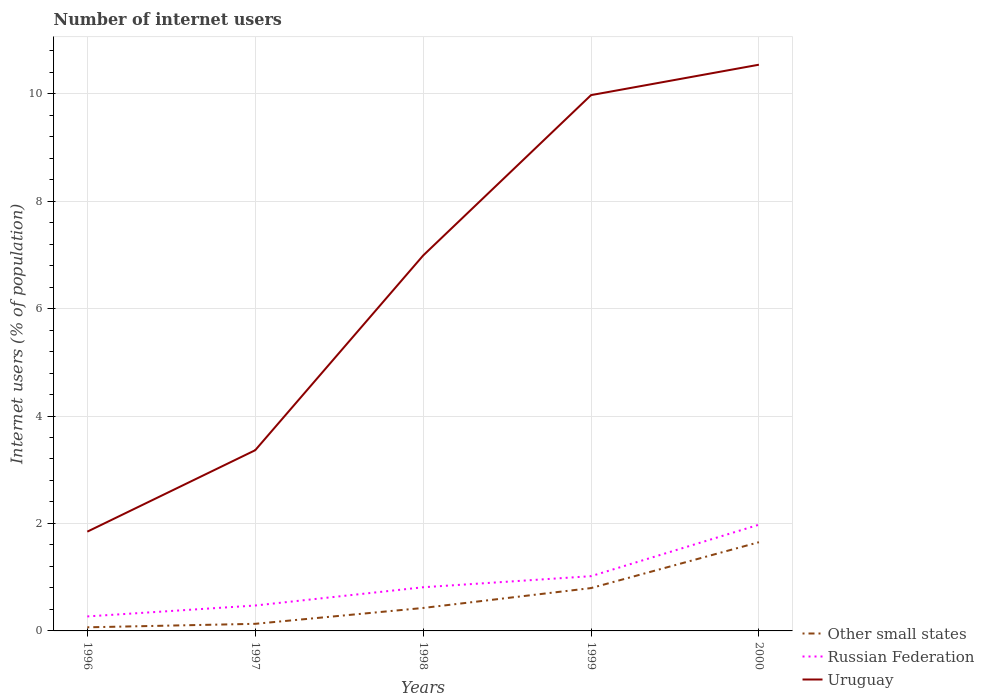How many different coloured lines are there?
Offer a terse response. 3. Does the line corresponding to Russian Federation intersect with the line corresponding to Other small states?
Your response must be concise. No. Is the number of lines equal to the number of legend labels?
Ensure brevity in your answer.  Yes. Across all years, what is the maximum number of internet users in Other small states?
Provide a short and direct response. 0.07. What is the total number of internet users in Uruguay in the graph?
Offer a terse response. -5.14. What is the difference between the highest and the second highest number of internet users in Uruguay?
Give a very brief answer. 8.69. Is the number of internet users in Other small states strictly greater than the number of internet users in Uruguay over the years?
Provide a short and direct response. Yes. How many lines are there?
Make the answer very short. 3. Are the values on the major ticks of Y-axis written in scientific E-notation?
Offer a very short reply. No. Does the graph contain any zero values?
Your answer should be very brief. No. Does the graph contain grids?
Your answer should be compact. Yes. Where does the legend appear in the graph?
Give a very brief answer. Bottom right. What is the title of the graph?
Ensure brevity in your answer.  Number of internet users. What is the label or title of the X-axis?
Offer a terse response. Years. What is the label or title of the Y-axis?
Your answer should be compact. Internet users (% of population). What is the Internet users (% of population) of Other small states in 1996?
Make the answer very short. 0.07. What is the Internet users (% of population) of Russian Federation in 1996?
Offer a very short reply. 0.27. What is the Internet users (% of population) in Uruguay in 1996?
Your answer should be very brief. 1.85. What is the Internet users (% of population) in Other small states in 1997?
Give a very brief answer. 0.13. What is the Internet users (% of population) of Russian Federation in 1997?
Make the answer very short. 0.47. What is the Internet users (% of population) in Uruguay in 1997?
Provide a short and direct response. 3.36. What is the Internet users (% of population) in Other small states in 1998?
Provide a short and direct response. 0.43. What is the Internet users (% of population) in Russian Federation in 1998?
Give a very brief answer. 0.81. What is the Internet users (% of population) of Uruguay in 1998?
Ensure brevity in your answer.  6.99. What is the Internet users (% of population) of Other small states in 1999?
Offer a terse response. 0.8. What is the Internet users (% of population) in Russian Federation in 1999?
Your response must be concise. 1.02. What is the Internet users (% of population) of Uruguay in 1999?
Make the answer very short. 9.97. What is the Internet users (% of population) of Other small states in 2000?
Your answer should be compact. 1.65. What is the Internet users (% of population) of Russian Federation in 2000?
Provide a short and direct response. 1.98. What is the Internet users (% of population) in Uruguay in 2000?
Make the answer very short. 10.54. Across all years, what is the maximum Internet users (% of population) in Other small states?
Provide a succinct answer. 1.65. Across all years, what is the maximum Internet users (% of population) in Russian Federation?
Give a very brief answer. 1.98. Across all years, what is the maximum Internet users (% of population) of Uruguay?
Your response must be concise. 10.54. Across all years, what is the minimum Internet users (% of population) of Other small states?
Offer a terse response. 0.07. Across all years, what is the minimum Internet users (% of population) in Russian Federation?
Provide a succinct answer. 0.27. Across all years, what is the minimum Internet users (% of population) of Uruguay?
Give a very brief answer. 1.85. What is the total Internet users (% of population) in Other small states in the graph?
Your response must be concise. 3.08. What is the total Internet users (% of population) in Russian Federation in the graph?
Keep it short and to the point. 4.55. What is the total Internet users (% of population) in Uruguay in the graph?
Make the answer very short. 32.71. What is the difference between the Internet users (% of population) of Other small states in 1996 and that in 1997?
Your answer should be very brief. -0.06. What is the difference between the Internet users (% of population) in Russian Federation in 1996 and that in 1997?
Provide a short and direct response. -0.2. What is the difference between the Internet users (% of population) of Uruguay in 1996 and that in 1997?
Keep it short and to the point. -1.52. What is the difference between the Internet users (% of population) of Other small states in 1996 and that in 1998?
Ensure brevity in your answer.  -0.36. What is the difference between the Internet users (% of population) of Russian Federation in 1996 and that in 1998?
Offer a terse response. -0.54. What is the difference between the Internet users (% of population) in Uruguay in 1996 and that in 1998?
Provide a short and direct response. -5.14. What is the difference between the Internet users (% of population) in Other small states in 1996 and that in 1999?
Offer a very short reply. -0.73. What is the difference between the Internet users (% of population) of Russian Federation in 1996 and that in 1999?
Your answer should be compact. -0.75. What is the difference between the Internet users (% of population) in Uruguay in 1996 and that in 1999?
Your answer should be very brief. -8.13. What is the difference between the Internet users (% of population) of Other small states in 1996 and that in 2000?
Provide a short and direct response. -1.58. What is the difference between the Internet users (% of population) of Russian Federation in 1996 and that in 2000?
Provide a succinct answer. -1.71. What is the difference between the Internet users (% of population) of Uruguay in 1996 and that in 2000?
Keep it short and to the point. -8.69. What is the difference between the Internet users (% of population) in Other small states in 1997 and that in 1998?
Offer a terse response. -0.3. What is the difference between the Internet users (% of population) of Russian Federation in 1997 and that in 1998?
Provide a succinct answer. -0.34. What is the difference between the Internet users (% of population) in Uruguay in 1997 and that in 1998?
Your response must be concise. -3.62. What is the difference between the Internet users (% of population) of Other small states in 1997 and that in 1999?
Give a very brief answer. -0.67. What is the difference between the Internet users (% of population) of Russian Federation in 1997 and that in 1999?
Offer a very short reply. -0.55. What is the difference between the Internet users (% of population) in Uruguay in 1997 and that in 1999?
Make the answer very short. -6.61. What is the difference between the Internet users (% of population) of Other small states in 1997 and that in 2000?
Give a very brief answer. -1.52. What is the difference between the Internet users (% of population) in Russian Federation in 1997 and that in 2000?
Offer a very short reply. -1.5. What is the difference between the Internet users (% of population) in Uruguay in 1997 and that in 2000?
Ensure brevity in your answer.  -7.18. What is the difference between the Internet users (% of population) in Other small states in 1998 and that in 1999?
Make the answer very short. -0.37. What is the difference between the Internet users (% of population) of Russian Federation in 1998 and that in 1999?
Make the answer very short. -0.21. What is the difference between the Internet users (% of population) of Uruguay in 1998 and that in 1999?
Keep it short and to the point. -2.99. What is the difference between the Internet users (% of population) of Other small states in 1998 and that in 2000?
Ensure brevity in your answer.  -1.22. What is the difference between the Internet users (% of population) of Russian Federation in 1998 and that in 2000?
Ensure brevity in your answer.  -1.16. What is the difference between the Internet users (% of population) in Uruguay in 1998 and that in 2000?
Provide a succinct answer. -3.55. What is the difference between the Internet users (% of population) in Other small states in 1999 and that in 2000?
Your response must be concise. -0.85. What is the difference between the Internet users (% of population) in Russian Federation in 1999 and that in 2000?
Offer a very short reply. -0.96. What is the difference between the Internet users (% of population) in Uruguay in 1999 and that in 2000?
Provide a succinct answer. -0.57. What is the difference between the Internet users (% of population) of Other small states in 1996 and the Internet users (% of population) of Russian Federation in 1997?
Your response must be concise. -0.41. What is the difference between the Internet users (% of population) of Other small states in 1996 and the Internet users (% of population) of Uruguay in 1997?
Offer a terse response. -3.3. What is the difference between the Internet users (% of population) of Russian Federation in 1996 and the Internet users (% of population) of Uruguay in 1997?
Your response must be concise. -3.09. What is the difference between the Internet users (% of population) of Other small states in 1996 and the Internet users (% of population) of Russian Federation in 1998?
Your answer should be very brief. -0.75. What is the difference between the Internet users (% of population) in Other small states in 1996 and the Internet users (% of population) in Uruguay in 1998?
Provide a short and direct response. -6.92. What is the difference between the Internet users (% of population) in Russian Federation in 1996 and the Internet users (% of population) in Uruguay in 1998?
Give a very brief answer. -6.72. What is the difference between the Internet users (% of population) of Other small states in 1996 and the Internet users (% of population) of Russian Federation in 1999?
Provide a short and direct response. -0.95. What is the difference between the Internet users (% of population) of Other small states in 1996 and the Internet users (% of population) of Uruguay in 1999?
Give a very brief answer. -9.91. What is the difference between the Internet users (% of population) of Russian Federation in 1996 and the Internet users (% of population) of Uruguay in 1999?
Provide a succinct answer. -9.7. What is the difference between the Internet users (% of population) in Other small states in 1996 and the Internet users (% of population) in Russian Federation in 2000?
Offer a terse response. -1.91. What is the difference between the Internet users (% of population) of Other small states in 1996 and the Internet users (% of population) of Uruguay in 2000?
Offer a terse response. -10.47. What is the difference between the Internet users (% of population) in Russian Federation in 1996 and the Internet users (% of population) in Uruguay in 2000?
Your answer should be very brief. -10.27. What is the difference between the Internet users (% of population) of Other small states in 1997 and the Internet users (% of population) of Russian Federation in 1998?
Your answer should be compact. -0.68. What is the difference between the Internet users (% of population) of Other small states in 1997 and the Internet users (% of population) of Uruguay in 1998?
Offer a terse response. -6.85. What is the difference between the Internet users (% of population) in Russian Federation in 1997 and the Internet users (% of population) in Uruguay in 1998?
Ensure brevity in your answer.  -6.51. What is the difference between the Internet users (% of population) of Other small states in 1997 and the Internet users (% of population) of Russian Federation in 1999?
Give a very brief answer. -0.89. What is the difference between the Internet users (% of population) of Other small states in 1997 and the Internet users (% of population) of Uruguay in 1999?
Ensure brevity in your answer.  -9.84. What is the difference between the Internet users (% of population) in Russian Federation in 1997 and the Internet users (% of population) in Uruguay in 1999?
Offer a very short reply. -9.5. What is the difference between the Internet users (% of population) in Other small states in 1997 and the Internet users (% of population) in Russian Federation in 2000?
Offer a very short reply. -1.85. What is the difference between the Internet users (% of population) of Other small states in 1997 and the Internet users (% of population) of Uruguay in 2000?
Offer a terse response. -10.41. What is the difference between the Internet users (% of population) in Russian Federation in 1997 and the Internet users (% of population) in Uruguay in 2000?
Give a very brief answer. -10.07. What is the difference between the Internet users (% of population) of Other small states in 1998 and the Internet users (% of population) of Russian Federation in 1999?
Ensure brevity in your answer.  -0.59. What is the difference between the Internet users (% of population) in Other small states in 1998 and the Internet users (% of population) in Uruguay in 1999?
Your answer should be compact. -9.55. What is the difference between the Internet users (% of population) of Russian Federation in 1998 and the Internet users (% of population) of Uruguay in 1999?
Give a very brief answer. -9.16. What is the difference between the Internet users (% of population) of Other small states in 1998 and the Internet users (% of population) of Russian Federation in 2000?
Make the answer very short. -1.55. What is the difference between the Internet users (% of population) in Other small states in 1998 and the Internet users (% of population) in Uruguay in 2000?
Your response must be concise. -10.11. What is the difference between the Internet users (% of population) in Russian Federation in 1998 and the Internet users (% of population) in Uruguay in 2000?
Your response must be concise. -9.73. What is the difference between the Internet users (% of population) in Other small states in 1999 and the Internet users (% of population) in Russian Federation in 2000?
Make the answer very short. -1.18. What is the difference between the Internet users (% of population) in Other small states in 1999 and the Internet users (% of population) in Uruguay in 2000?
Your answer should be compact. -9.74. What is the difference between the Internet users (% of population) in Russian Federation in 1999 and the Internet users (% of population) in Uruguay in 2000?
Ensure brevity in your answer.  -9.52. What is the average Internet users (% of population) of Other small states per year?
Your response must be concise. 0.62. What is the average Internet users (% of population) of Russian Federation per year?
Make the answer very short. 0.91. What is the average Internet users (% of population) in Uruguay per year?
Keep it short and to the point. 6.54. In the year 1996, what is the difference between the Internet users (% of population) of Other small states and Internet users (% of population) of Russian Federation?
Provide a short and direct response. -0.2. In the year 1996, what is the difference between the Internet users (% of population) in Other small states and Internet users (% of population) in Uruguay?
Offer a very short reply. -1.78. In the year 1996, what is the difference between the Internet users (% of population) in Russian Federation and Internet users (% of population) in Uruguay?
Offer a very short reply. -1.58. In the year 1997, what is the difference between the Internet users (% of population) in Other small states and Internet users (% of population) in Russian Federation?
Offer a very short reply. -0.34. In the year 1997, what is the difference between the Internet users (% of population) of Other small states and Internet users (% of population) of Uruguay?
Offer a very short reply. -3.23. In the year 1997, what is the difference between the Internet users (% of population) in Russian Federation and Internet users (% of population) in Uruguay?
Ensure brevity in your answer.  -2.89. In the year 1998, what is the difference between the Internet users (% of population) of Other small states and Internet users (% of population) of Russian Federation?
Make the answer very short. -0.39. In the year 1998, what is the difference between the Internet users (% of population) in Other small states and Internet users (% of population) in Uruguay?
Keep it short and to the point. -6.56. In the year 1998, what is the difference between the Internet users (% of population) of Russian Federation and Internet users (% of population) of Uruguay?
Provide a short and direct response. -6.17. In the year 1999, what is the difference between the Internet users (% of population) of Other small states and Internet users (% of population) of Russian Federation?
Your response must be concise. -0.22. In the year 1999, what is the difference between the Internet users (% of population) in Other small states and Internet users (% of population) in Uruguay?
Make the answer very short. -9.18. In the year 1999, what is the difference between the Internet users (% of population) of Russian Federation and Internet users (% of population) of Uruguay?
Your answer should be compact. -8.95. In the year 2000, what is the difference between the Internet users (% of population) of Other small states and Internet users (% of population) of Russian Federation?
Offer a terse response. -0.33. In the year 2000, what is the difference between the Internet users (% of population) of Other small states and Internet users (% of population) of Uruguay?
Ensure brevity in your answer.  -8.89. In the year 2000, what is the difference between the Internet users (% of population) of Russian Federation and Internet users (% of population) of Uruguay?
Offer a terse response. -8.56. What is the ratio of the Internet users (% of population) in Other small states in 1996 to that in 1997?
Offer a very short reply. 0.51. What is the ratio of the Internet users (% of population) in Russian Federation in 1996 to that in 1997?
Keep it short and to the point. 0.57. What is the ratio of the Internet users (% of population) in Uruguay in 1996 to that in 1997?
Offer a very short reply. 0.55. What is the ratio of the Internet users (% of population) in Other small states in 1996 to that in 1998?
Give a very brief answer. 0.16. What is the ratio of the Internet users (% of population) of Russian Federation in 1996 to that in 1998?
Offer a very short reply. 0.33. What is the ratio of the Internet users (% of population) in Uruguay in 1996 to that in 1998?
Keep it short and to the point. 0.26. What is the ratio of the Internet users (% of population) of Other small states in 1996 to that in 1999?
Give a very brief answer. 0.08. What is the ratio of the Internet users (% of population) in Russian Federation in 1996 to that in 1999?
Provide a short and direct response. 0.26. What is the ratio of the Internet users (% of population) of Uruguay in 1996 to that in 1999?
Provide a short and direct response. 0.19. What is the ratio of the Internet users (% of population) of Other small states in 1996 to that in 2000?
Your answer should be compact. 0.04. What is the ratio of the Internet users (% of population) of Russian Federation in 1996 to that in 2000?
Make the answer very short. 0.14. What is the ratio of the Internet users (% of population) in Uruguay in 1996 to that in 2000?
Keep it short and to the point. 0.18. What is the ratio of the Internet users (% of population) in Other small states in 1997 to that in 1998?
Your answer should be very brief. 0.31. What is the ratio of the Internet users (% of population) of Russian Federation in 1997 to that in 1998?
Give a very brief answer. 0.58. What is the ratio of the Internet users (% of population) in Uruguay in 1997 to that in 1998?
Provide a short and direct response. 0.48. What is the ratio of the Internet users (% of population) of Other small states in 1997 to that in 1999?
Offer a terse response. 0.17. What is the ratio of the Internet users (% of population) of Russian Federation in 1997 to that in 1999?
Ensure brevity in your answer.  0.46. What is the ratio of the Internet users (% of population) in Uruguay in 1997 to that in 1999?
Give a very brief answer. 0.34. What is the ratio of the Internet users (% of population) of Russian Federation in 1997 to that in 2000?
Keep it short and to the point. 0.24. What is the ratio of the Internet users (% of population) in Uruguay in 1997 to that in 2000?
Give a very brief answer. 0.32. What is the ratio of the Internet users (% of population) in Other small states in 1998 to that in 1999?
Your answer should be compact. 0.54. What is the ratio of the Internet users (% of population) of Russian Federation in 1998 to that in 1999?
Make the answer very short. 0.8. What is the ratio of the Internet users (% of population) of Uruguay in 1998 to that in 1999?
Give a very brief answer. 0.7. What is the ratio of the Internet users (% of population) of Other small states in 1998 to that in 2000?
Your response must be concise. 0.26. What is the ratio of the Internet users (% of population) of Russian Federation in 1998 to that in 2000?
Give a very brief answer. 0.41. What is the ratio of the Internet users (% of population) of Uruguay in 1998 to that in 2000?
Your answer should be very brief. 0.66. What is the ratio of the Internet users (% of population) in Other small states in 1999 to that in 2000?
Give a very brief answer. 0.48. What is the ratio of the Internet users (% of population) in Russian Federation in 1999 to that in 2000?
Your answer should be compact. 0.52. What is the ratio of the Internet users (% of population) of Uruguay in 1999 to that in 2000?
Keep it short and to the point. 0.95. What is the difference between the highest and the second highest Internet users (% of population) of Other small states?
Keep it short and to the point. 0.85. What is the difference between the highest and the second highest Internet users (% of population) in Russian Federation?
Make the answer very short. 0.96. What is the difference between the highest and the second highest Internet users (% of population) in Uruguay?
Your response must be concise. 0.57. What is the difference between the highest and the lowest Internet users (% of population) in Other small states?
Offer a very short reply. 1.58. What is the difference between the highest and the lowest Internet users (% of population) in Russian Federation?
Make the answer very short. 1.71. What is the difference between the highest and the lowest Internet users (% of population) of Uruguay?
Provide a short and direct response. 8.69. 